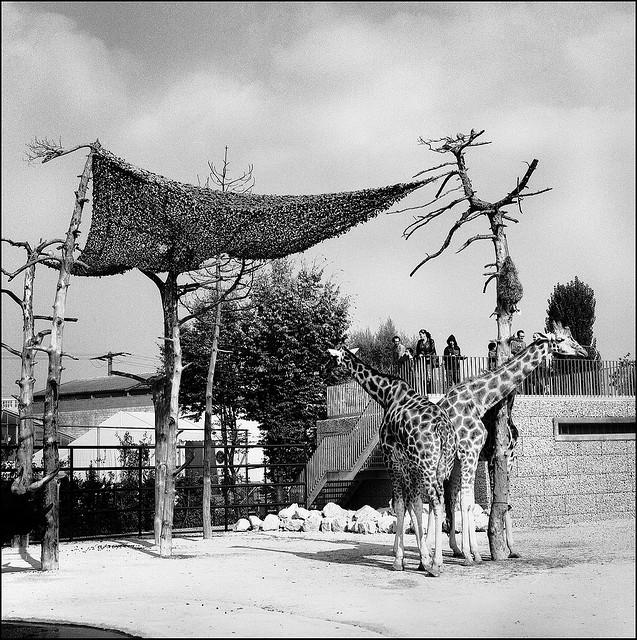Why are the people behind rails? zoo 